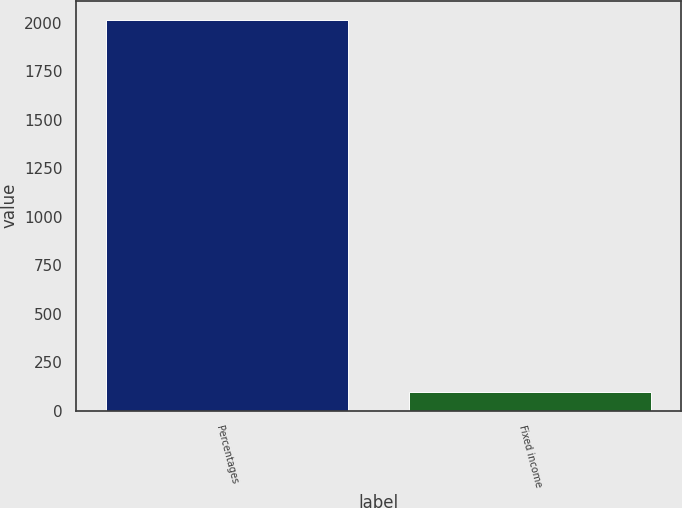Convert chart. <chart><loc_0><loc_0><loc_500><loc_500><bar_chart><fcel>Percentages<fcel>Fixed income<nl><fcel>2015<fcel>98<nl></chart> 